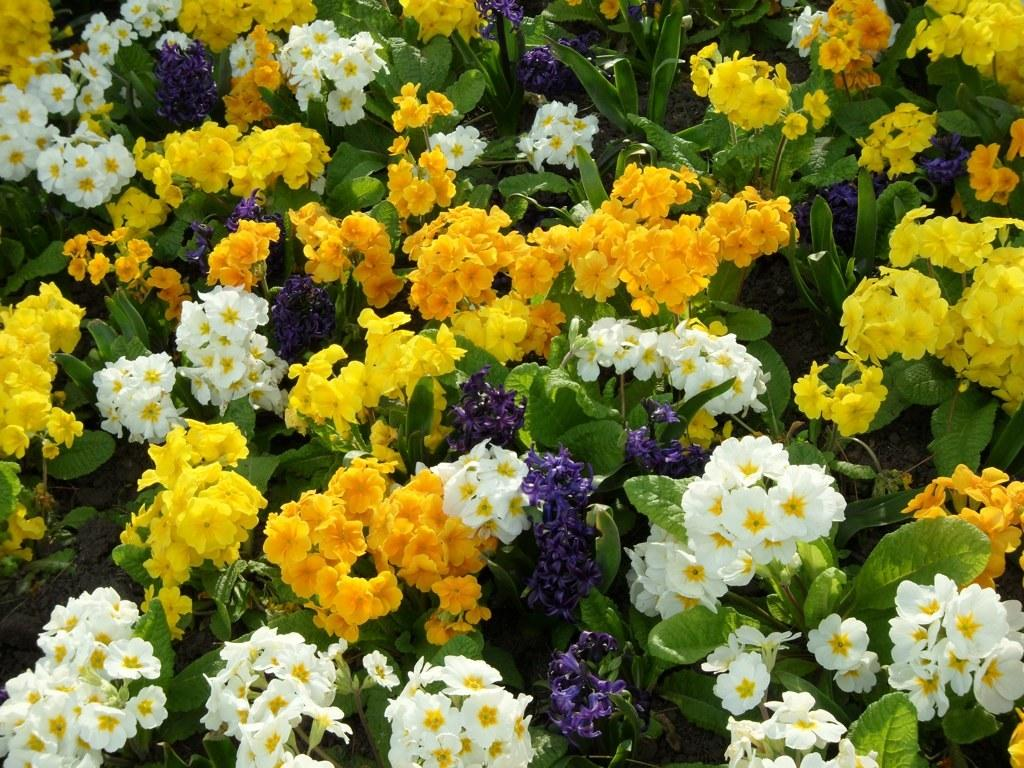What colors of flowers can be seen on the plant in the image? There are yellow, white, and purple flowers on the plant in the image. What other parts of the plant are visible besides the flowers? The plant has leaves at the bottom. What type of hat is the plant wearing in the image? There is no hat present on the plant in the image. Can you describe the aftermath of the crime that took place in the image? There is no crime or aftermath mentioned in the image; it features a plant with flowers and leaves. 